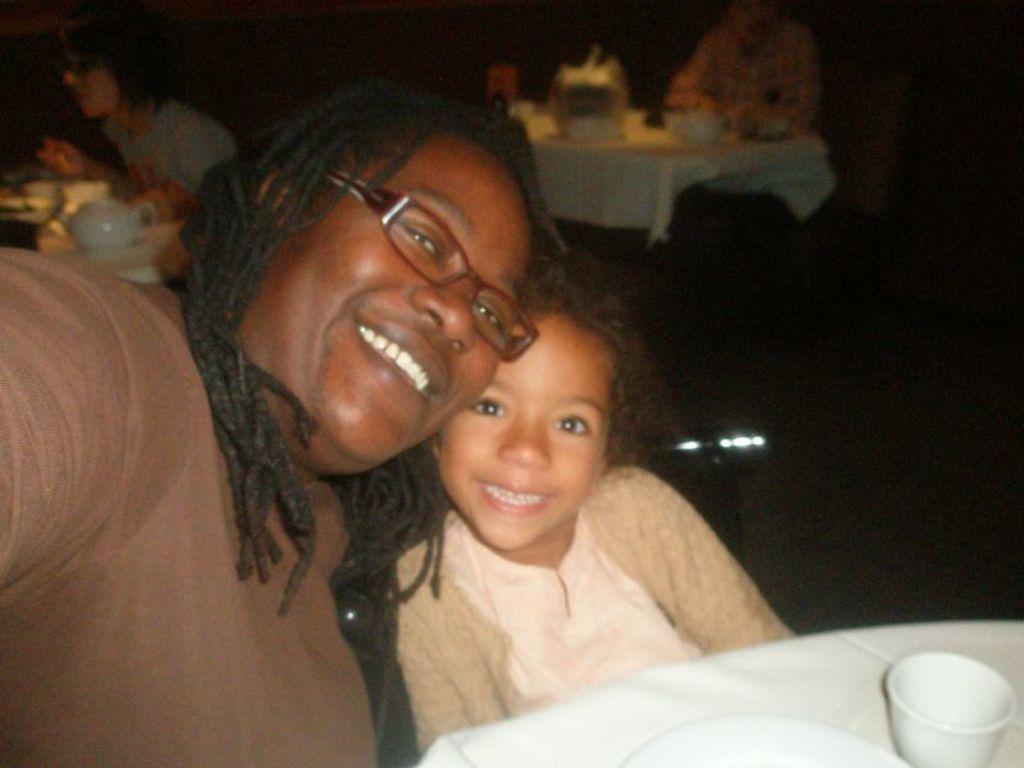How would you summarize this image in a sentence or two? In this image I can see few people are sitting and I can see the cup and few objects on the tables. Background is in black color. 